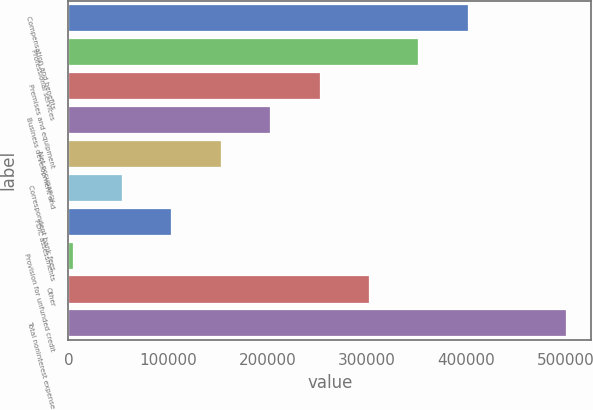<chart> <loc_0><loc_0><loc_500><loc_500><bar_chart><fcel>Compensation and benefits<fcel>Professional services<fcel>Premises and equipment<fcel>Business development and<fcel>Net occupancy<fcel>Correspondent bank fees<fcel>FDIC assessments<fcel>Provision for unfunded credit<fcel>Other<fcel>Total noninterest expense<nl><fcel>401382<fcel>351759<fcel>252512<fcel>202889<fcel>153266<fcel>54020.1<fcel>103643<fcel>4397<fcel>302136<fcel>500628<nl></chart> 